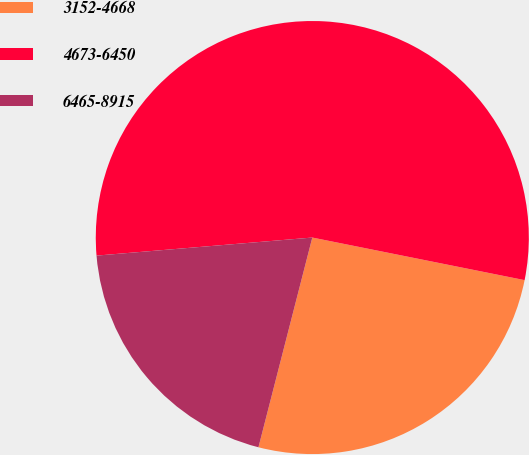Convert chart. <chart><loc_0><loc_0><loc_500><loc_500><pie_chart><fcel>3152-4668<fcel>4673-6450<fcel>6465-8915<nl><fcel>25.85%<fcel>54.48%<fcel>19.67%<nl></chart> 